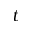<formula> <loc_0><loc_0><loc_500><loc_500>t</formula> 